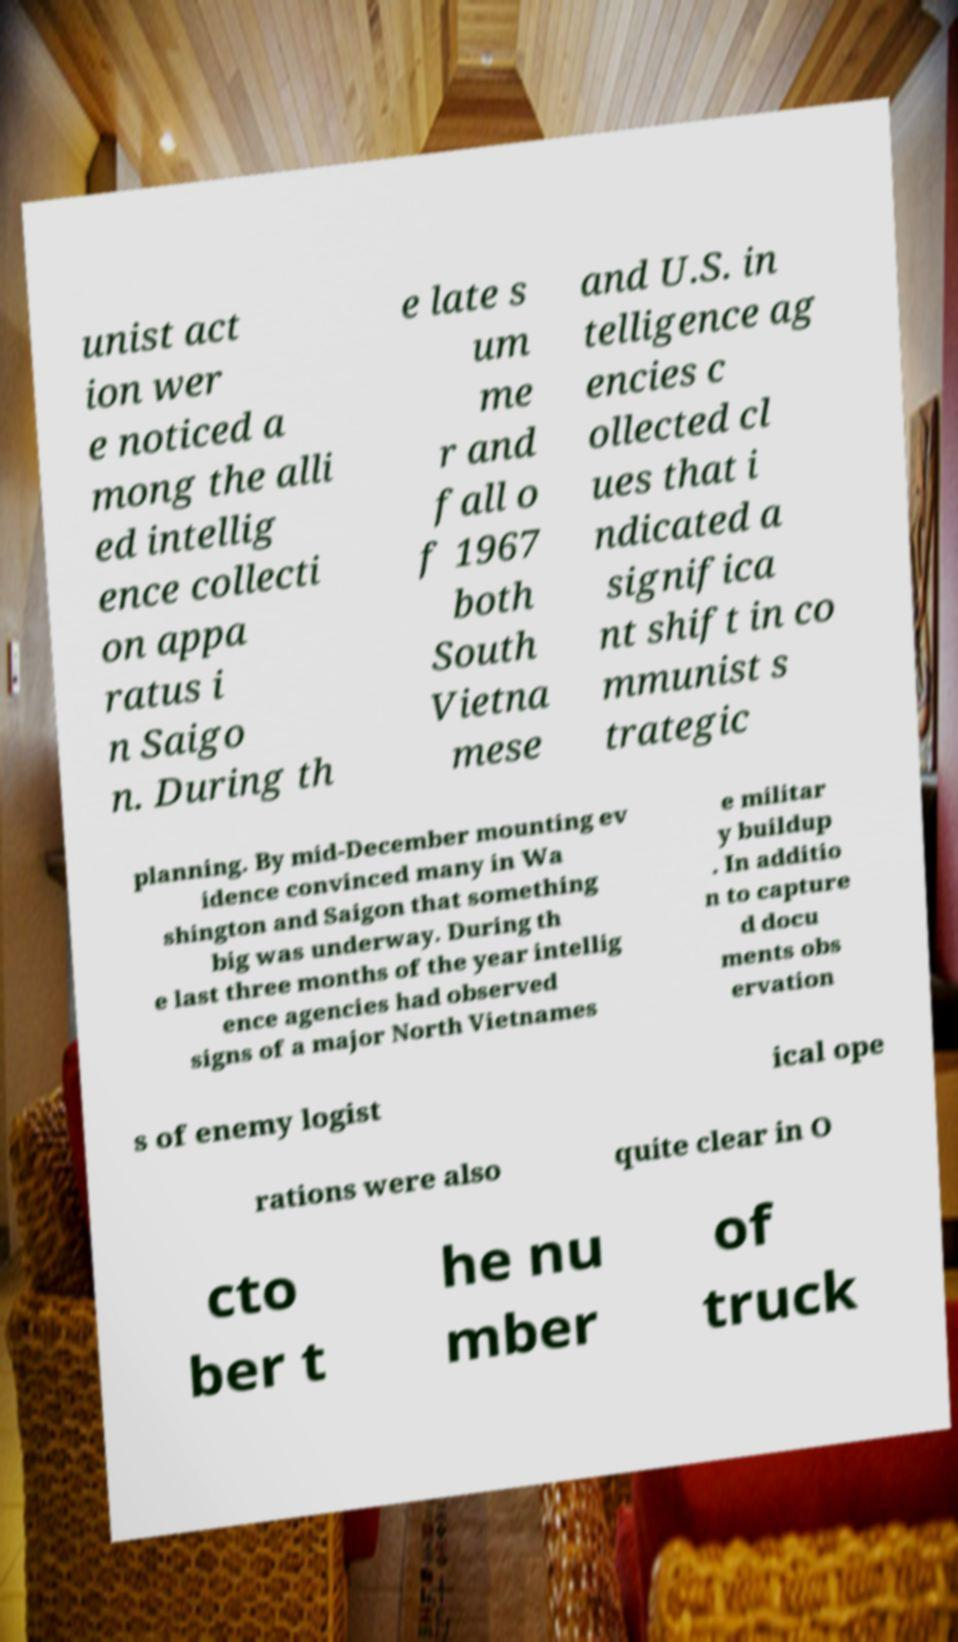Could you assist in decoding the text presented in this image and type it out clearly? unist act ion wer e noticed a mong the alli ed intellig ence collecti on appa ratus i n Saigo n. During th e late s um me r and fall o f 1967 both South Vietna mese and U.S. in telligence ag encies c ollected cl ues that i ndicated a significa nt shift in co mmunist s trategic planning. By mid-December mounting ev idence convinced many in Wa shington and Saigon that something big was underway. During th e last three months of the year intellig ence agencies had observed signs of a major North Vietnames e militar y buildup . In additio n to capture d docu ments obs ervation s of enemy logist ical ope rations were also quite clear in O cto ber t he nu mber of truck 